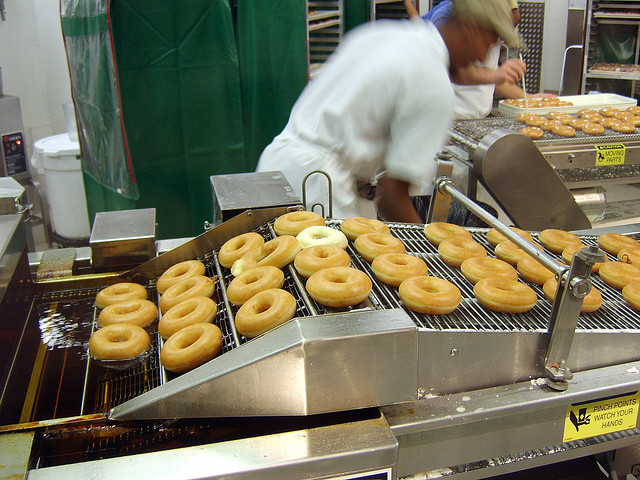Please identify all text content in this image. WATCH HANDS 